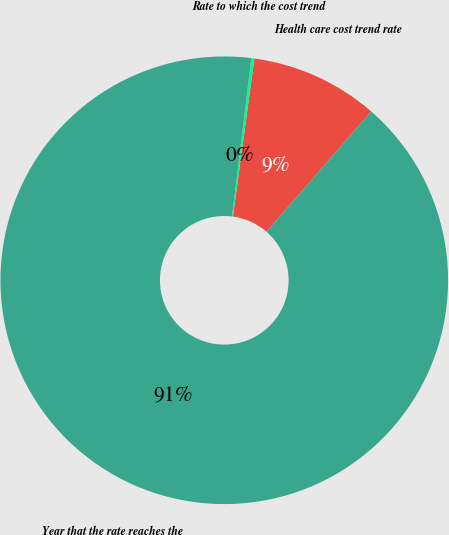<chart> <loc_0><loc_0><loc_500><loc_500><pie_chart><fcel>Health care cost trend rate<fcel>Rate to which the cost trend<fcel>Year that the rate reaches the<nl><fcel>9.25%<fcel>0.22%<fcel>90.52%<nl></chart> 